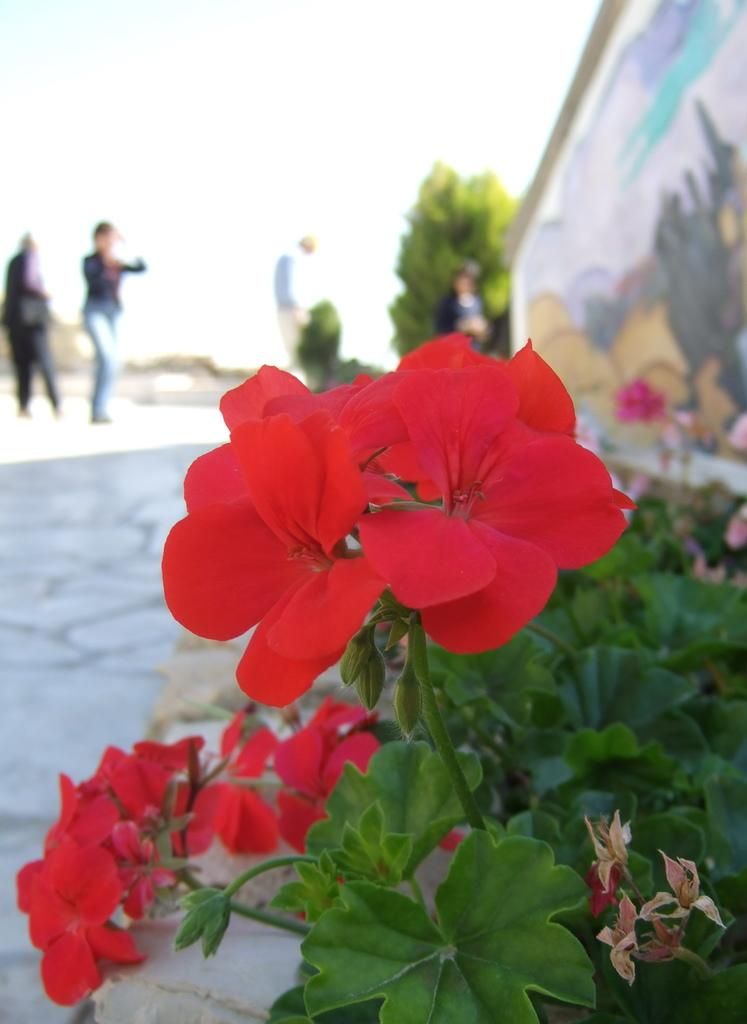What type of plant is featured in the image? There is a plant with flowers in the image. Can you describe the background of the image? In the background, there are plants with flowers, a painting on the wall, persons standing on the ground, trees, and the sky. How many types of plants with flowers can be seen in the image? There is one plant with flowers in the foreground and additional plants with flowers in the background, making a total of at least two types of plants with flowers visible. What is the natural environment visible in the background? Trees and the sky are visible in the background. How many frogs are sitting on the dime in the image? There are no frogs or dimes present in the image. What type of division is being performed by the persons in the background? There is no indication of any division being performed by the persons in the background; they are simply standing on the ground. 